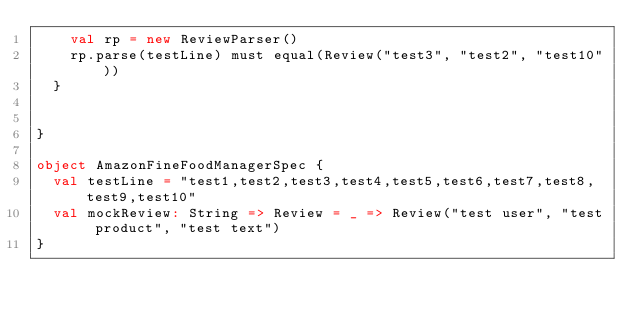Convert code to text. <code><loc_0><loc_0><loc_500><loc_500><_Scala_>    val rp = new ReviewParser()
    rp.parse(testLine) must equal(Review("test3", "test2", "test10"))
  }

  
}

object AmazonFineFoodManagerSpec {
  val testLine = "test1,test2,test3,test4,test5,test6,test7,test8,test9,test10"
  val mockReview: String => Review = _ => Review("test user", "test product", "test text")
}

</code> 